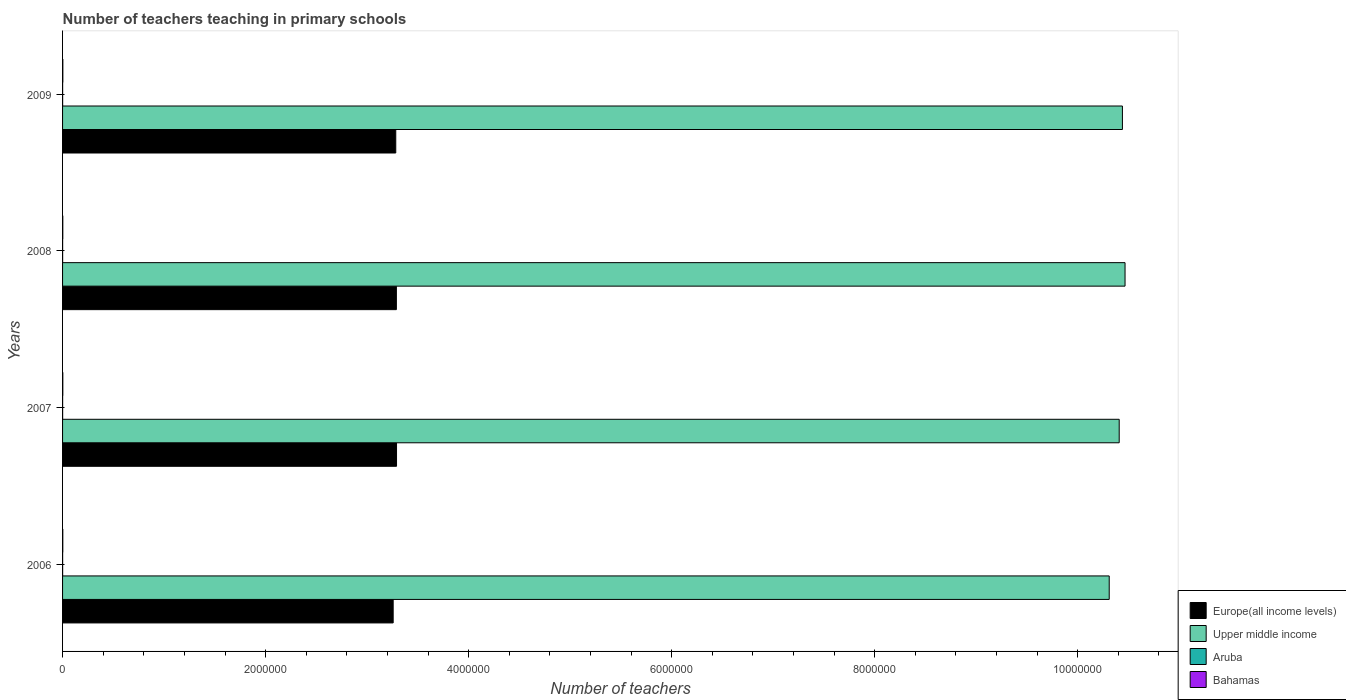How many different coloured bars are there?
Make the answer very short. 4. Are the number of bars per tick equal to the number of legend labels?
Your response must be concise. Yes. Are the number of bars on each tick of the Y-axis equal?
Make the answer very short. Yes. How many bars are there on the 1st tick from the top?
Make the answer very short. 4. What is the number of teachers teaching in primary schools in Europe(all income levels) in 2009?
Your answer should be compact. 3.28e+06. Across all years, what is the maximum number of teachers teaching in primary schools in Bahamas?
Your answer should be compact. 2683. Across all years, what is the minimum number of teachers teaching in primary schools in Aruba?
Keep it short and to the point. 572. In which year was the number of teachers teaching in primary schools in Europe(all income levels) maximum?
Provide a short and direct response. 2007. In which year was the number of teachers teaching in primary schools in Upper middle income minimum?
Provide a short and direct response. 2006. What is the total number of teachers teaching in primary schools in Upper middle income in the graph?
Make the answer very short. 4.16e+07. What is the difference between the number of teachers teaching in primary schools in Bahamas in 2008 and that in 2009?
Provide a short and direct response. -350. What is the difference between the number of teachers teaching in primary schools in Europe(all income levels) in 2006 and the number of teachers teaching in primary schools in Aruba in 2009?
Provide a succinct answer. 3.26e+06. What is the average number of teachers teaching in primary schools in Aruba per year?
Your answer should be very brief. 581.75. In the year 2007, what is the difference between the number of teachers teaching in primary schools in Aruba and number of teachers teaching in primary schools in Europe(all income levels)?
Offer a very short reply. -3.29e+06. In how many years, is the number of teachers teaching in primary schools in Upper middle income greater than 6000000 ?
Your response must be concise. 4. What is the ratio of the number of teachers teaching in primary schools in Upper middle income in 2007 to that in 2008?
Provide a short and direct response. 0.99. Is the number of teachers teaching in primary schools in Aruba in 2007 less than that in 2009?
Make the answer very short. No. Is the difference between the number of teachers teaching in primary schools in Aruba in 2008 and 2009 greater than the difference between the number of teachers teaching in primary schools in Europe(all income levels) in 2008 and 2009?
Your answer should be compact. No. What is the difference between the highest and the second highest number of teachers teaching in primary schools in Aruba?
Offer a terse response. 12. What is the difference between the highest and the lowest number of teachers teaching in primary schools in Upper middle income?
Give a very brief answer. 1.56e+05. Is the sum of the number of teachers teaching in primary schools in Aruba in 2006 and 2009 greater than the maximum number of teachers teaching in primary schools in Europe(all income levels) across all years?
Keep it short and to the point. No. What does the 1st bar from the top in 2008 represents?
Provide a short and direct response. Bahamas. What does the 2nd bar from the bottom in 2006 represents?
Ensure brevity in your answer.  Upper middle income. Is it the case that in every year, the sum of the number of teachers teaching in primary schools in Aruba and number of teachers teaching in primary schools in Bahamas is greater than the number of teachers teaching in primary schools in Europe(all income levels)?
Make the answer very short. No. How many bars are there?
Make the answer very short. 16. Are all the bars in the graph horizontal?
Offer a terse response. Yes. What is the difference between two consecutive major ticks on the X-axis?
Make the answer very short. 2.00e+06. Are the values on the major ticks of X-axis written in scientific E-notation?
Make the answer very short. No. Does the graph contain any zero values?
Offer a terse response. No. Does the graph contain grids?
Provide a succinct answer. No. How many legend labels are there?
Your response must be concise. 4. How are the legend labels stacked?
Keep it short and to the point. Vertical. What is the title of the graph?
Offer a very short reply. Number of teachers teaching in primary schools. What is the label or title of the X-axis?
Your response must be concise. Number of teachers. What is the label or title of the Y-axis?
Your response must be concise. Years. What is the Number of teachers of Europe(all income levels) in 2006?
Provide a succinct answer. 3.26e+06. What is the Number of teachers in Upper middle income in 2006?
Make the answer very short. 1.03e+07. What is the Number of teachers of Aruba in 2006?
Offer a very short reply. 572. What is the Number of teachers of Bahamas in 2006?
Offer a very short reply. 2335. What is the Number of teachers in Europe(all income levels) in 2007?
Provide a succinct answer. 3.29e+06. What is the Number of teachers of Upper middle income in 2007?
Keep it short and to the point. 1.04e+07. What is the Number of teachers of Aruba in 2007?
Make the answer very short. 594. What is the Number of teachers of Bahamas in 2007?
Ensure brevity in your answer.  2420. What is the Number of teachers in Europe(all income levels) in 2008?
Provide a short and direct response. 3.29e+06. What is the Number of teachers in Upper middle income in 2008?
Keep it short and to the point. 1.05e+07. What is the Number of teachers in Aruba in 2008?
Make the answer very short. 579. What is the Number of teachers of Bahamas in 2008?
Your answer should be very brief. 2333. What is the Number of teachers in Europe(all income levels) in 2009?
Ensure brevity in your answer.  3.28e+06. What is the Number of teachers of Upper middle income in 2009?
Offer a terse response. 1.04e+07. What is the Number of teachers of Aruba in 2009?
Ensure brevity in your answer.  582. What is the Number of teachers of Bahamas in 2009?
Give a very brief answer. 2683. Across all years, what is the maximum Number of teachers in Europe(all income levels)?
Your response must be concise. 3.29e+06. Across all years, what is the maximum Number of teachers of Upper middle income?
Give a very brief answer. 1.05e+07. Across all years, what is the maximum Number of teachers of Aruba?
Your answer should be very brief. 594. Across all years, what is the maximum Number of teachers in Bahamas?
Your response must be concise. 2683. Across all years, what is the minimum Number of teachers in Europe(all income levels)?
Keep it short and to the point. 3.26e+06. Across all years, what is the minimum Number of teachers in Upper middle income?
Your response must be concise. 1.03e+07. Across all years, what is the minimum Number of teachers of Aruba?
Ensure brevity in your answer.  572. Across all years, what is the minimum Number of teachers in Bahamas?
Give a very brief answer. 2333. What is the total Number of teachers of Europe(all income levels) in the graph?
Your response must be concise. 1.31e+07. What is the total Number of teachers in Upper middle income in the graph?
Ensure brevity in your answer.  4.16e+07. What is the total Number of teachers of Aruba in the graph?
Keep it short and to the point. 2327. What is the total Number of teachers in Bahamas in the graph?
Give a very brief answer. 9771. What is the difference between the Number of teachers of Europe(all income levels) in 2006 and that in 2007?
Give a very brief answer. -3.32e+04. What is the difference between the Number of teachers in Upper middle income in 2006 and that in 2007?
Offer a very short reply. -9.83e+04. What is the difference between the Number of teachers in Aruba in 2006 and that in 2007?
Give a very brief answer. -22. What is the difference between the Number of teachers of Bahamas in 2006 and that in 2007?
Offer a terse response. -85. What is the difference between the Number of teachers in Europe(all income levels) in 2006 and that in 2008?
Your answer should be compact. -3.15e+04. What is the difference between the Number of teachers of Upper middle income in 2006 and that in 2008?
Your answer should be compact. -1.56e+05. What is the difference between the Number of teachers in Europe(all income levels) in 2006 and that in 2009?
Keep it short and to the point. -2.55e+04. What is the difference between the Number of teachers in Upper middle income in 2006 and that in 2009?
Your answer should be very brief. -1.30e+05. What is the difference between the Number of teachers of Bahamas in 2006 and that in 2009?
Offer a very short reply. -348. What is the difference between the Number of teachers in Europe(all income levels) in 2007 and that in 2008?
Your answer should be compact. 1630.5. What is the difference between the Number of teachers of Upper middle income in 2007 and that in 2008?
Offer a very short reply. -5.76e+04. What is the difference between the Number of teachers of Aruba in 2007 and that in 2008?
Your answer should be compact. 15. What is the difference between the Number of teachers of Europe(all income levels) in 2007 and that in 2009?
Offer a very short reply. 7643.75. What is the difference between the Number of teachers in Upper middle income in 2007 and that in 2009?
Ensure brevity in your answer.  -3.17e+04. What is the difference between the Number of teachers of Aruba in 2007 and that in 2009?
Your answer should be very brief. 12. What is the difference between the Number of teachers in Bahamas in 2007 and that in 2009?
Offer a very short reply. -263. What is the difference between the Number of teachers in Europe(all income levels) in 2008 and that in 2009?
Provide a short and direct response. 6013.25. What is the difference between the Number of teachers of Upper middle income in 2008 and that in 2009?
Keep it short and to the point. 2.58e+04. What is the difference between the Number of teachers of Aruba in 2008 and that in 2009?
Give a very brief answer. -3. What is the difference between the Number of teachers of Bahamas in 2008 and that in 2009?
Your answer should be very brief. -350. What is the difference between the Number of teachers of Europe(all income levels) in 2006 and the Number of teachers of Upper middle income in 2007?
Provide a short and direct response. -7.15e+06. What is the difference between the Number of teachers in Europe(all income levels) in 2006 and the Number of teachers in Aruba in 2007?
Offer a terse response. 3.26e+06. What is the difference between the Number of teachers in Europe(all income levels) in 2006 and the Number of teachers in Bahamas in 2007?
Your response must be concise. 3.25e+06. What is the difference between the Number of teachers in Upper middle income in 2006 and the Number of teachers in Aruba in 2007?
Your response must be concise. 1.03e+07. What is the difference between the Number of teachers in Upper middle income in 2006 and the Number of teachers in Bahamas in 2007?
Keep it short and to the point. 1.03e+07. What is the difference between the Number of teachers of Aruba in 2006 and the Number of teachers of Bahamas in 2007?
Provide a short and direct response. -1848. What is the difference between the Number of teachers of Europe(all income levels) in 2006 and the Number of teachers of Upper middle income in 2008?
Your answer should be very brief. -7.21e+06. What is the difference between the Number of teachers in Europe(all income levels) in 2006 and the Number of teachers in Aruba in 2008?
Your response must be concise. 3.26e+06. What is the difference between the Number of teachers in Europe(all income levels) in 2006 and the Number of teachers in Bahamas in 2008?
Give a very brief answer. 3.25e+06. What is the difference between the Number of teachers in Upper middle income in 2006 and the Number of teachers in Aruba in 2008?
Provide a short and direct response. 1.03e+07. What is the difference between the Number of teachers in Upper middle income in 2006 and the Number of teachers in Bahamas in 2008?
Offer a very short reply. 1.03e+07. What is the difference between the Number of teachers of Aruba in 2006 and the Number of teachers of Bahamas in 2008?
Keep it short and to the point. -1761. What is the difference between the Number of teachers in Europe(all income levels) in 2006 and the Number of teachers in Upper middle income in 2009?
Provide a short and direct response. -7.18e+06. What is the difference between the Number of teachers in Europe(all income levels) in 2006 and the Number of teachers in Aruba in 2009?
Offer a very short reply. 3.26e+06. What is the difference between the Number of teachers of Europe(all income levels) in 2006 and the Number of teachers of Bahamas in 2009?
Provide a short and direct response. 3.25e+06. What is the difference between the Number of teachers in Upper middle income in 2006 and the Number of teachers in Aruba in 2009?
Your response must be concise. 1.03e+07. What is the difference between the Number of teachers in Upper middle income in 2006 and the Number of teachers in Bahamas in 2009?
Your answer should be compact. 1.03e+07. What is the difference between the Number of teachers of Aruba in 2006 and the Number of teachers of Bahamas in 2009?
Provide a short and direct response. -2111. What is the difference between the Number of teachers in Europe(all income levels) in 2007 and the Number of teachers in Upper middle income in 2008?
Provide a short and direct response. -7.18e+06. What is the difference between the Number of teachers in Europe(all income levels) in 2007 and the Number of teachers in Aruba in 2008?
Provide a short and direct response. 3.29e+06. What is the difference between the Number of teachers in Europe(all income levels) in 2007 and the Number of teachers in Bahamas in 2008?
Your answer should be compact. 3.29e+06. What is the difference between the Number of teachers in Upper middle income in 2007 and the Number of teachers in Aruba in 2008?
Offer a terse response. 1.04e+07. What is the difference between the Number of teachers in Upper middle income in 2007 and the Number of teachers in Bahamas in 2008?
Give a very brief answer. 1.04e+07. What is the difference between the Number of teachers in Aruba in 2007 and the Number of teachers in Bahamas in 2008?
Provide a succinct answer. -1739. What is the difference between the Number of teachers of Europe(all income levels) in 2007 and the Number of teachers of Upper middle income in 2009?
Provide a succinct answer. -7.15e+06. What is the difference between the Number of teachers in Europe(all income levels) in 2007 and the Number of teachers in Aruba in 2009?
Offer a very short reply. 3.29e+06. What is the difference between the Number of teachers of Europe(all income levels) in 2007 and the Number of teachers of Bahamas in 2009?
Offer a very short reply. 3.29e+06. What is the difference between the Number of teachers of Upper middle income in 2007 and the Number of teachers of Aruba in 2009?
Provide a succinct answer. 1.04e+07. What is the difference between the Number of teachers of Upper middle income in 2007 and the Number of teachers of Bahamas in 2009?
Provide a succinct answer. 1.04e+07. What is the difference between the Number of teachers in Aruba in 2007 and the Number of teachers in Bahamas in 2009?
Your response must be concise. -2089. What is the difference between the Number of teachers in Europe(all income levels) in 2008 and the Number of teachers in Upper middle income in 2009?
Ensure brevity in your answer.  -7.15e+06. What is the difference between the Number of teachers in Europe(all income levels) in 2008 and the Number of teachers in Aruba in 2009?
Offer a terse response. 3.29e+06. What is the difference between the Number of teachers in Europe(all income levels) in 2008 and the Number of teachers in Bahamas in 2009?
Make the answer very short. 3.29e+06. What is the difference between the Number of teachers in Upper middle income in 2008 and the Number of teachers in Aruba in 2009?
Offer a very short reply. 1.05e+07. What is the difference between the Number of teachers of Upper middle income in 2008 and the Number of teachers of Bahamas in 2009?
Your answer should be compact. 1.05e+07. What is the difference between the Number of teachers of Aruba in 2008 and the Number of teachers of Bahamas in 2009?
Your response must be concise. -2104. What is the average Number of teachers in Europe(all income levels) per year?
Provide a succinct answer. 3.28e+06. What is the average Number of teachers in Upper middle income per year?
Ensure brevity in your answer.  1.04e+07. What is the average Number of teachers of Aruba per year?
Keep it short and to the point. 581.75. What is the average Number of teachers in Bahamas per year?
Give a very brief answer. 2442.75. In the year 2006, what is the difference between the Number of teachers of Europe(all income levels) and Number of teachers of Upper middle income?
Ensure brevity in your answer.  -7.05e+06. In the year 2006, what is the difference between the Number of teachers of Europe(all income levels) and Number of teachers of Aruba?
Your response must be concise. 3.26e+06. In the year 2006, what is the difference between the Number of teachers in Europe(all income levels) and Number of teachers in Bahamas?
Offer a very short reply. 3.25e+06. In the year 2006, what is the difference between the Number of teachers in Upper middle income and Number of teachers in Aruba?
Provide a succinct answer. 1.03e+07. In the year 2006, what is the difference between the Number of teachers of Upper middle income and Number of teachers of Bahamas?
Offer a terse response. 1.03e+07. In the year 2006, what is the difference between the Number of teachers of Aruba and Number of teachers of Bahamas?
Your response must be concise. -1763. In the year 2007, what is the difference between the Number of teachers of Europe(all income levels) and Number of teachers of Upper middle income?
Give a very brief answer. -7.12e+06. In the year 2007, what is the difference between the Number of teachers of Europe(all income levels) and Number of teachers of Aruba?
Make the answer very short. 3.29e+06. In the year 2007, what is the difference between the Number of teachers in Europe(all income levels) and Number of teachers in Bahamas?
Ensure brevity in your answer.  3.29e+06. In the year 2007, what is the difference between the Number of teachers of Upper middle income and Number of teachers of Aruba?
Provide a succinct answer. 1.04e+07. In the year 2007, what is the difference between the Number of teachers of Upper middle income and Number of teachers of Bahamas?
Your answer should be compact. 1.04e+07. In the year 2007, what is the difference between the Number of teachers in Aruba and Number of teachers in Bahamas?
Provide a short and direct response. -1826. In the year 2008, what is the difference between the Number of teachers of Europe(all income levels) and Number of teachers of Upper middle income?
Your answer should be compact. -7.18e+06. In the year 2008, what is the difference between the Number of teachers of Europe(all income levels) and Number of teachers of Aruba?
Offer a terse response. 3.29e+06. In the year 2008, what is the difference between the Number of teachers of Europe(all income levels) and Number of teachers of Bahamas?
Your response must be concise. 3.29e+06. In the year 2008, what is the difference between the Number of teachers of Upper middle income and Number of teachers of Aruba?
Offer a very short reply. 1.05e+07. In the year 2008, what is the difference between the Number of teachers of Upper middle income and Number of teachers of Bahamas?
Your response must be concise. 1.05e+07. In the year 2008, what is the difference between the Number of teachers of Aruba and Number of teachers of Bahamas?
Offer a very short reply. -1754. In the year 2009, what is the difference between the Number of teachers of Europe(all income levels) and Number of teachers of Upper middle income?
Give a very brief answer. -7.16e+06. In the year 2009, what is the difference between the Number of teachers of Europe(all income levels) and Number of teachers of Aruba?
Offer a very short reply. 3.28e+06. In the year 2009, what is the difference between the Number of teachers of Europe(all income levels) and Number of teachers of Bahamas?
Provide a succinct answer. 3.28e+06. In the year 2009, what is the difference between the Number of teachers in Upper middle income and Number of teachers in Aruba?
Your answer should be compact. 1.04e+07. In the year 2009, what is the difference between the Number of teachers of Upper middle income and Number of teachers of Bahamas?
Your answer should be very brief. 1.04e+07. In the year 2009, what is the difference between the Number of teachers of Aruba and Number of teachers of Bahamas?
Keep it short and to the point. -2101. What is the ratio of the Number of teachers of Upper middle income in 2006 to that in 2007?
Your answer should be very brief. 0.99. What is the ratio of the Number of teachers of Bahamas in 2006 to that in 2007?
Offer a very short reply. 0.96. What is the ratio of the Number of teachers of Upper middle income in 2006 to that in 2008?
Your answer should be very brief. 0.99. What is the ratio of the Number of teachers of Aruba in 2006 to that in 2008?
Offer a terse response. 0.99. What is the ratio of the Number of teachers in Bahamas in 2006 to that in 2008?
Offer a terse response. 1. What is the ratio of the Number of teachers of Upper middle income in 2006 to that in 2009?
Keep it short and to the point. 0.99. What is the ratio of the Number of teachers in Aruba in 2006 to that in 2009?
Your answer should be very brief. 0.98. What is the ratio of the Number of teachers in Bahamas in 2006 to that in 2009?
Ensure brevity in your answer.  0.87. What is the ratio of the Number of teachers in Upper middle income in 2007 to that in 2008?
Offer a very short reply. 0.99. What is the ratio of the Number of teachers in Aruba in 2007 to that in 2008?
Offer a very short reply. 1.03. What is the ratio of the Number of teachers in Bahamas in 2007 to that in 2008?
Offer a very short reply. 1.04. What is the ratio of the Number of teachers of Upper middle income in 2007 to that in 2009?
Offer a terse response. 1. What is the ratio of the Number of teachers in Aruba in 2007 to that in 2009?
Your answer should be compact. 1.02. What is the ratio of the Number of teachers in Bahamas in 2007 to that in 2009?
Your answer should be compact. 0.9. What is the ratio of the Number of teachers of Europe(all income levels) in 2008 to that in 2009?
Offer a terse response. 1. What is the ratio of the Number of teachers of Upper middle income in 2008 to that in 2009?
Offer a terse response. 1. What is the ratio of the Number of teachers of Aruba in 2008 to that in 2009?
Offer a very short reply. 0.99. What is the ratio of the Number of teachers of Bahamas in 2008 to that in 2009?
Provide a short and direct response. 0.87. What is the difference between the highest and the second highest Number of teachers of Europe(all income levels)?
Provide a succinct answer. 1630.5. What is the difference between the highest and the second highest Number of teachers of Upper middle income?
Make the answer very short. 2.58e+04. What is the difference between the highest and the second highest Number of teachers of Aruba?
Your answer should be compact. 12. What is the difference between the highest and the second highest Number of teachers of Bahamas?
Keep it short and to the point. 263. What is the difference between the highest and the lowest Number of teachers of Europe(all income levels)?
Keep it short and to the point. 3.32e+04. What is the difference between the highest and the lowest Number of teachers in Upper middle income?
Your response must be concise. 1.56e+05. What is the difference between the highest and the lowest Number of teachers of Bahamas?
Offer a very short reply. 350. 